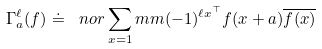<formula> <loc_0><loc_0><loc_500><loc_500>\Gamma _ { a } ^ { \ell } ( f ) \doteq \ n o r \sum _ { x = 1 } ^ { \ } m m ( - 1 ) ^ { \ell x ^ { \top } } f ( x + a ) \overline { f ( x ) }</formula> 